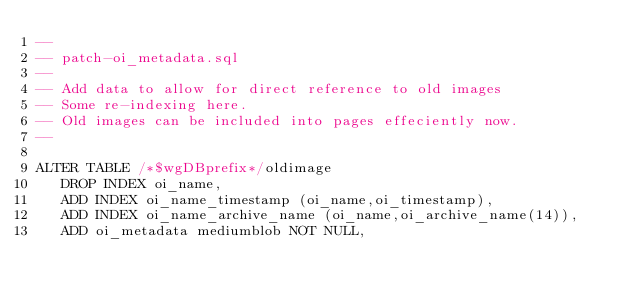<code> <loc_0><loc_0><loc_500><loc_500><_SQL_>-- 
-- patch-oi_metadata.sql
-- 
-- Add data to allow for direct reference to old images
-- Some re-indexing here.
-- Old images can be included into pages effeciently now.
-- 

ALTER TABLE /*$wgDBprefix*/oldimage
   DROP INDEX oi_name,
   ADD INDEX oi_name_timestamp (oi_name,oi_timestamp),
   ADD INDEX oi_name_archive_name (oi_name,oi_archive_name(14)),
   ADD oi_metadata mediumblob NOT NULL,</code> 